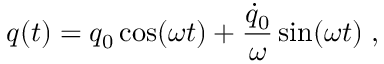<formula> <loc_0><loc_0><loc_500><loc_500>q ( t ) = q _ { 0 } \cos ( \omega t ) + { \frac { \dot { q } _ { 0 } } { \omega } } \sin ( \omega t ) \, ,</formula> 